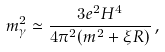Convert formula to latex. <formula><loc_0><loc_0><loc_500><loc_500>m _ { \gamma } ^ { 2 } \simeq \frac { 3 e ^ { 2 } H ^ { 4 } } { 4 \pi ^ { 2 } ( m ^ { 2 } + \xi R ) } \, ,</formula> 